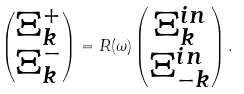Convert formula to latex. <formula><loc_0><loc_0><loc_500><loc_500>\begin{pmatrix} \Xi ^ { + } _ { k } \\ \Xi ^ { - } _ { k } \end{pmatrix} = R ( \omega ) \begin{pmatrix} \Xi _ { k } ^ { i n } \\ \Xi _ { - k } ^ { i n } \end{pmatrix} .</formula> 